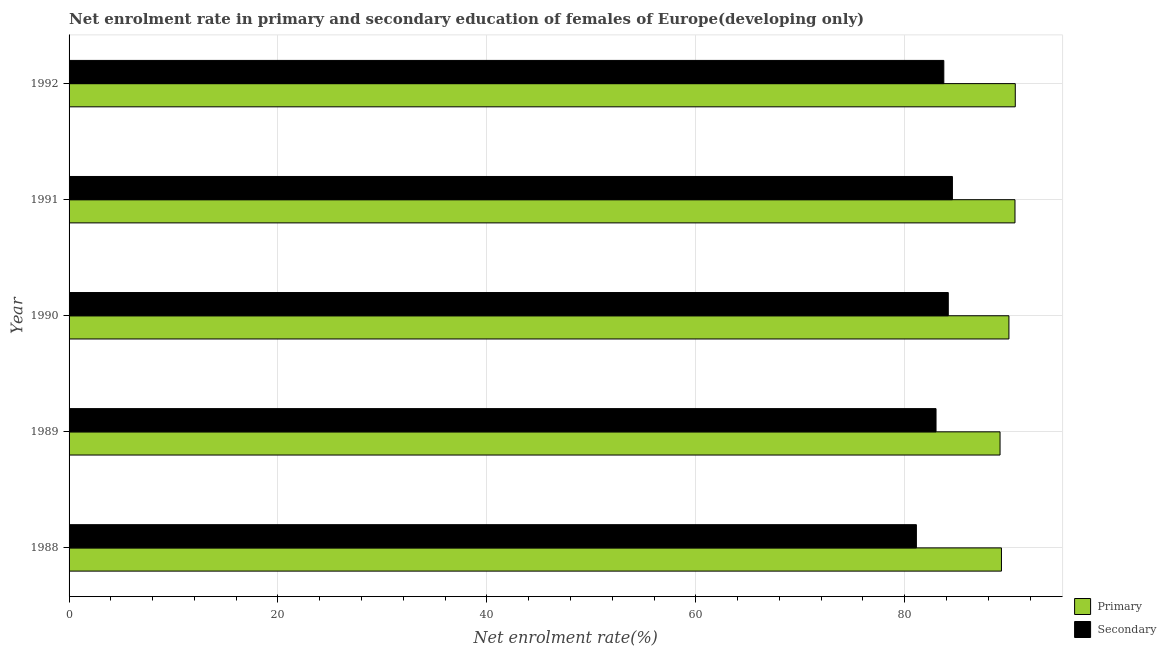Are the number of bars per tick equal to the number of legend labels?
Your response must be concise. Yes. How many bars are there on the 3rd tick from the top?
Keep it short and to the point. 2. How many bars are there on the 1st tick from the bottom?
Ensure brevity in your answer.  2. What is the label of the 2nd group of bars from the top?
Offer a very short reply. 1991. In how many cases, is the number of bars for a given year not equal to the number of legend labels?
Give a very brief answer. 0. What is the enrollment rate in primary education in 1988?
Provide a succinct answer. 89.26. Across all years, what is the maximum enrollment rate in primary education?
Your answer should be very brief. 90.59. Across all years, what is the minimum enrollment rate in primary education?
Provide a short and direct response. 89.13. In which year was the enrollment rate in secondary education maximum?
Provide a succinct answer. 1991. In which year was the enrollment rate in secondary education minimum?
Ensure brevity in your answer.  1988. What is the total enrollment rate in secondary education in the graph?
Your answer should be compact. 416.61. What is the difference between the enrollment rate in secondary education in 1988 and that in 1991?
Your response must be concise. -3.45. What is the difference between the enrollment rate in primary education in 1992 and the enrollment rate in secondary education in 1989?
Ensure brevity in your answer.  7.59. What is the average enrollment rate in primary education per year?
Give a very brief answer. 89.9. In the year 1988, what is the difference between the enrollment rate in primary education and enrollment rate in secondary education?
Offer a very short reply. 8.14. What is the ratio of the enrollment rate in primary education in 1991 to that in 1992?
Your response must be concise. 1. Is the difference between the enrollment rate in secondary education in 1990 and 1991 greater than the difference between the enrollment rate in primary education in 1990 and 1991?
Give a very brief answer. Yes. What is the difference between the highest and the second highest enrollment rate in secondary education?
Provide a short and direct response. 0.4. What is the difference between the highest and the lowest enrollment rate in primary education?
Offer a very short reply. 1.46. What does the 2nd bar from the top in 1989 represents?
Offer a terse response. Primary. What does the 1st bar from the bottom in 1990 represents?
Give a very brief answer. Primary. How many bars are there?
Offer a very short reply. 10. Are all the bars in the graph horizontal?
Offer a very short reply. Yes. How many years are there in the graph?
Give a very brief answer. 5. Are the values on the major ticks of X-axis written in scientific E-notation?
Ensure brevity in your answer.  No. Does the graph contain grids?
Offer a very short reply. Yes. How many legend labels are there?
Offer a terse response. 2. How are the legend labels stacked?
Keep it short and to the point. Vertical. What is the title of the graph?
Provide a succinct answer. Net enrolment rate in primary and secondary education of females of Europe(developing only). Does "RDB concessional" appear as one of the legend labels in the graph?
Your answer should be compact. No. What is the label or title of the X-axis?
Your answer should be compact. Net enrolment rate(%). What is the label or title of the Y-axis?
Provide a short and direct response. Year. What is the Net enrolment rate(%) of Primary in 1988?
Your response must be concise. 89.26. What is the Net enrolment rate(%) in Secondary in 1988?
Offer a terse response. 81.12. What is the Net enrolment rate(%) of Primary in 1989?
Provide a succinct answer. 89.13. What is the Net enrolment rate(%) in Secondary in 1989?
Your response must be concise. 83. What is the Net enrolment rate(%) in Primary in 1990?
Ensure brevity in your answer.  89.98. What is the Net enrolment rate(%) in Secondary in 1990?
Your answer should be very brief. 84.17. What is the Net enrolment rate(%) in Primary in 1991?
Ensure brevity in your answer.  90.56. What is the Net enrolment rate(%) in Secondary in 1991?
Give a very brief answer. 84.57. What is the Net enrolment rate(%) in Primary in 1992?
Ensure brevity in your answer.  90.59. What is the Net enrolment rate(%) of Secondary in 1992?
Offer a terse response. 83.75. Across all years, what is the maximum Net enrolment rate(%) of Primary?
Provide a succinct answer. 90.59. Across all years, what is the maximum Net enrolment rate(%) of Secondary?
Give a very brief answer. 84.57. Across all years, what is the minimum Net enrolment rate(%) of Primary?
Your answer should be very brief. 89.13. Across all years, what is the minimum Net enrolment rate(%) in Secondary?
Your answer should be very brief. 81.12. What is the total Net enrolment rate(%) of Primary in the graph?
Offer a terse response. 449.52. What is the total Net enrolment rate(%) of Secondary in the graph?
Your response must be concise. 416.61. What is the difference between the Net enrolment rate(%) of Primary in 1988 and that in 1989?
Ensure brevity in your answer.  0.13. What is the difference between the Net enrolment rate(%) of Secondary in 1988 and that in 1989?
Ensure brevity in your answer.  -1.88. What is the difference between the Net enrolment rate(%) of Primary in 1988 and that in 1990?
Offer a very short reply. -0.72. What is the difference between the Net enrolment rate(%) of Secondary in 1988 and that in 1990?
Your response must be concise. -3.05. What is the difference between the Net enrolment rate(%) in Primary in 1988 and that in 1991?
Give a very brief answer. -1.3. What is the difference between the Net enrolment rate(%) in Secondary in 1988 and that in 1991?
Give a very brief answer. -3.45. What is the difference between the Net enrolment rate(%) of Primary in 1988 and that in 1992?
Keep it short and to the point. -1.32. What is the difference between the Net enrolment rate(%) in Secondary in 1988 and that in 1992?
Ensure brevity in your answer.  -2.63. What is the difference between the Net enrolment rate(%) of Primary in 1989 and that in 1990?
Offer a very short reply. -0.85. What is the difference between the Net enrolment rate(%) of Secondary in 1989 and that in 1990?
Give a very brief answer. -1.17. What is the difference between the Net enrolment rate(%) in Primary in 1989 and that in 1991?
Your response must be concise. -1.43. What is the difference between the Net enrolment rate(%) in Secondary in 1989 and that in 1991?
Provide a succinct answer. -1.57. What is the difference between the Net enrolment rate(%) in Primary in 1989 and that in 1992?
Keep it short and to the point. -1.46. What is the difference between the Net enrolment rate(%) of Secondary in 1989 and that in 1992?
Ensure brevity in your answer.  -0.75. What is the difference between the Net enrolment rate(%) in Primary in 1990 and that in 1991?
Your response must be concise. -0.58. What is the difference between the Net enrolment rate(%) in Secondary in 1990 and that in 1991?
Provide a short and direct response. -0.4. What is the difference between the Net enrolment rate(%) of Primary in 1990 and that in 1992?
Ensure brevity in your answer.  -0.61. What is the difference between the Net enrolment rate(%) of Secondary in 1990 and that in 1992?
Keep it short and to the point. 0.43. What is the difference between the Net enrolment rate(%) of Primary in 1991 and that in 1992?
Your response must be concise. -0.03. What is the difference between the Net enrolment rate(%) in Secondary in 1991 and that in 1992?
Your answer should be compact. 0.82. What is the difference between the Net enrolment rate(%) of Primary in 1988 and the Net enrolment rate(%) of Secondary in 1989?
Offer a terse response. 6.26. What is the difference between the Net enrolment rate(%) in Primary in 1988 and the Net enrolment rate(%) in Secondary in 1990?
Your response must be concise. 5.09. What is the difference between the Net enrolment rate(%) of Primary in 1988 and the Net enrolment rate(%) of Secondary in 1991?
Offer a terse response. 4.69. What is the difference between the Net enrolment rate(%) of Primary in 1988 and the Net enrolment rate(%) of Secondary in 1992?
Offer a very short reply. 5.52. What is the difference between the Net enrolment rate(%) in Primary in 1989 and the Net enrolment rate(%) in Secondary in 1990?
Provide a succinct answer. 4.96. What is the difference between the Net enrolment rate(%) of Primary in 1989 and the Net enrolment rate(%) of Secondary in 1991?
Make the answer very short. 4.56. What is the difference between the Net enrolment rate(%) in Primary in 1989 and the Net enrolment rate(%) in Secondary in 1992?
Offer a very short reply. 5.38. What is the difference between the Net enrolment rate(%) of Primary in 1990 and the Net enrolment rate(%) of Secondary in 1991?
Provide a succinct answer. 5.41. What is the difference between the Net enrolment rate(%) of Primary in 1990 and the Net enrolment rate(%) of Secondary in 1992?
Give a very brief answer. 6.23. What is the difference between the Net enrolment rate(%) in Primary in 1991 and the Net enrolment rate(%) in Secondary in 1992?
Offer a very short reply. 6.81. What is the average Net enrolment rate(%) in Primary per year?
Provide a short and direct response. 89.9. What is the average Net enrolment rate(%) in Secondary per year?
Your answer should be very brief. 83.32. In the year 1988, what is the difference between the Net enrolment rate(%) of Primary and Net enrolment rate(%) of Secondary?
Offer a very short reply. 8.14. In the year 1989, what is the difference between the Net enrolment rate(%) in Primary and Net enrolment rate(%) in Secondary?
Give a very brief answer. 6.13. In the year 1990, what is the difference between the Net enrolment rate(%) of Primary and Net enrolment rate(%) of Secondary?
Your answer should be compact. 5.81. In the year 1991, what is the difference between the Net enrolment rate(%) of Primary and Net enrolment rate(%) of Secondary?
Offer a terse response. 5.99. In the year 1992, what is the difference between the Net enrolment rate(%) in Primary and Net enrolment rate(%) in Secondary?
Give a very brief answer. 6.84. What is the ratio of the Net enrolment rate(%) of Primary in 1988 to that in 1989?
Offer a terse response. 1. What is the ratio of the Net enrolment rate(%) of Secondary in 1988 to that in 1989?
Provide a short and direct response. 0.98. What is the ratio of the Net enrolment rate(%) of Primary in 1988 to that in 1990?
Make the answer very short. 0.99. What is the ratio of the Net enrolment rate(%) of Secondary in 1988 to that in 1990?
Provide a succinct answer. 0.96. What is the ratio of the Net enrolment rate(%) in Primary in 1988 to that in 1991?
Offer a very short reply. 0.99. What is the ratio of the Net enrolment rate(%) in Secondary in 1988 to that in 1991?
Your response must be concise. 0.96. What is the ratio of the Net enrolment rate(%) in Primary in 1988 to that in 1992?
Provide a short and direct response. 0.99. What is the ratio of the Net enrolment rate(%) of Secondary in 1988 to that in 1992?
Make the answer very short. 0.97. What is the ratio of the Net enrolment rate(%) in Primary in 1989 to that in 1990?
Your answer should be compact. 0.99. What is the ratio of the Net enrolment rate(%) of Secondary in 1989 to that in 1990?
Ensure brevity in your answer.  0.99. What is the ratio of the Net enrolment rate(%) in Primary in 1989 to that in 1991?
Ensure brevity in your answer.  0.98. What is the ratio of the Net enrolment rate(%) in Secondary in 1989 to that in 1991?
Keep it short and to the point. 0.98. What is the ratio of the Net enrolment rate(%) of Primary in 1989 to that in 1992?
Ensure brevity in your answer.  0.98. What is the ratio of the Net enrolment rate(%) of Primary in 1990 to that in 1991?
Provide a short and direct response. 0.99. What is the ratio of the Net enrolment rate(%) in Primary in 1990 to that in 1992?
Give a very brief answer. 0.99. What is the ratio of the Net enrolment rate(%) in Secondary in 1990 to that in 1992?
Your answer should be compact. 1.01. What is the ratio of the Net enrolment rate(%) of Primary in 1991 to that in 1992?
Your answer should be very brief. 1. What is the ratio of the Net enrolment rate(%) of Secondary in 1991 to that in 1992?
Your answer should be very brief. 1.01. What is the difference between the highest and the second highest Net enrolment rate(%) of Primary?
Give a very brief answer. 0.03. What is the difference between the highest and the second highest Net enrolment rate(%) in Secondary?
Keep it short and to the point. 0.4. What is the difference between the highest and the lowest Net enrolment rate(%) in Primary?
Make the answer very short. 1.46. What is the difference between the highest and the lowest Net enrolment rate(%) of Secondary?
Give a very brief answer. 3.45. 